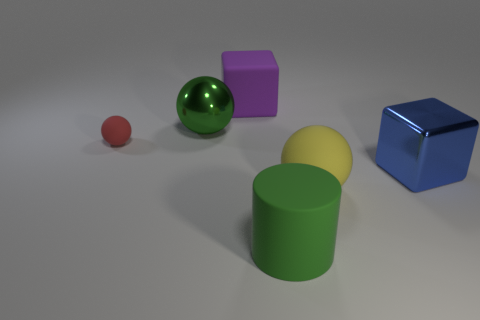Is the metallic ball the same color as the matte cube?
Make the answer very short. No. What shape is the green thing that is made of the same material as the big blue object?
Provide a succinct answer. Sphere. The purple rubber thing has what shape?
Offer a very short reply. Cube. What material is the other object that is the same shape as the big purple rubber thing?
Keep it short and to the point. Metal. How many gray objects are the same size as the cylinder?
Your answer should be compact. 0. Are there any yellow balls that are to the left of the big ball that is on the right side of the green rubber thing?
Provide a succinct answer. No. What number of brown objects are either large metal things or spheres?
Offer a very short reply. 0. The small matte sphere is what color?
Your answer should be compact. Red. There is a green cylinder that is the same material as the small red object; what is its size?
Make the answer very short. Large. What number of other yellow things are the same shape as the yellow object?
Keep it short and to the point. 0. 